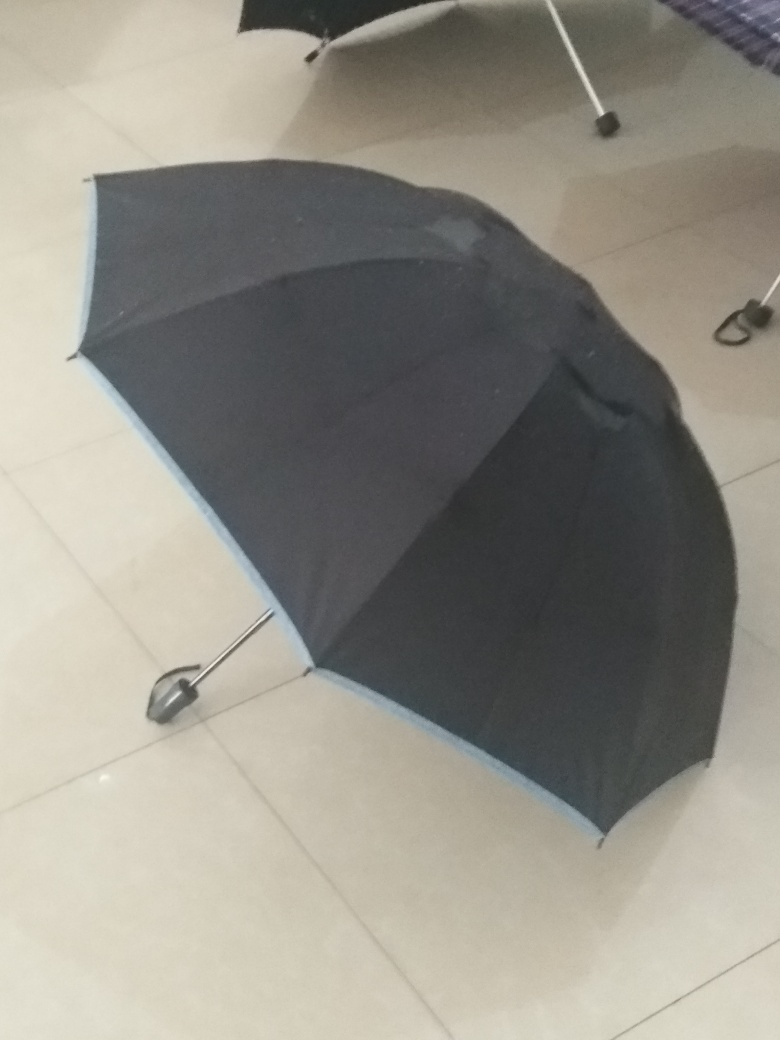Is the image slightly tilted? Yes, upon closer examination, the image does give the impression of being slightly tilted. The angle of the umbrella's handle and the direction in which it leans suggest the photo was captured with a slight tilt to the side. 